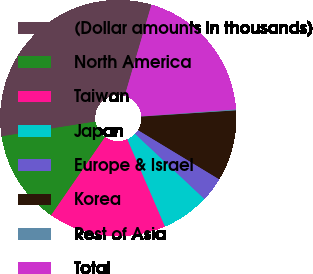<chart> <loc_0><loc_0><loc_500><loc_500><pie_chart><fcel>(Dollar amounts in thousands)<fcel>North America<fcel>Taiwan<fcel>Japan<fcel>Europe & Israel<fcel>Korea<fcel>Rest of Asia<fcel>Total<nl><fcel>32.03%<fcel>12.9%<fcel>16.09%<fcel>6.52%<fcel>3.33%<fcel>9.71%<fcel>0.14%<fcel>19.28%<nl></chart> 